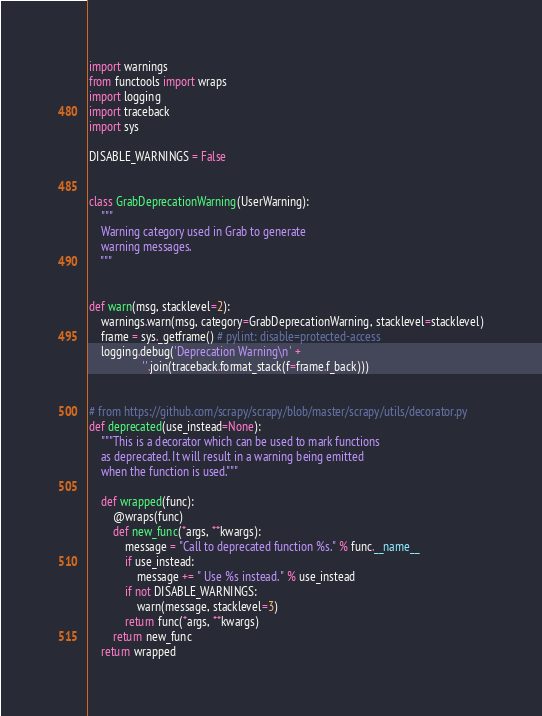Convert code to text. <code><loc_0><loc_0><loc_500><loc_500><_Python_>import warnings
from functools import wraps
import logging
import traceback
import sys

DISABLE_WARNINGS = False


class GrabDeprecationWarning(UserWarning):
    """
    Warning category used in Grab to generate
    warning messages.
    """


def warn(msg, stacklevel=2):
    warnings.warn(msg, category=GrabDeprecationWarning, stacklevel=stacklevel)
    frame = sys._getframe() # pylint: disable=protected-access
    logging.debug('Deprecation Warning\n' +
                  ''.join(traceback.format_stack(f=frame.f_back)))


# from https://github.com/scrapy/scrapy/blob/master/scrapy/utils/decorator.py
def deprecated(use_instead=None):
    """This is a decorator which can be used to mark functions
    as deprecated. It will result in a warning being emitted
    when the function is used."""

    def wrapped(func):
        @wraps(func)
        def new_func(*args, **kwargs):
            message = "Call to deprecated function %s." % func.__name__
            if use_instead:
                message += " Use %s instead." % use_instead
            if not DISABLE_WARNINGS:
                warn(message, stacklevel=3)
            return func(*args, **kwargs)
        return new_func
    return wrapped
</code> 